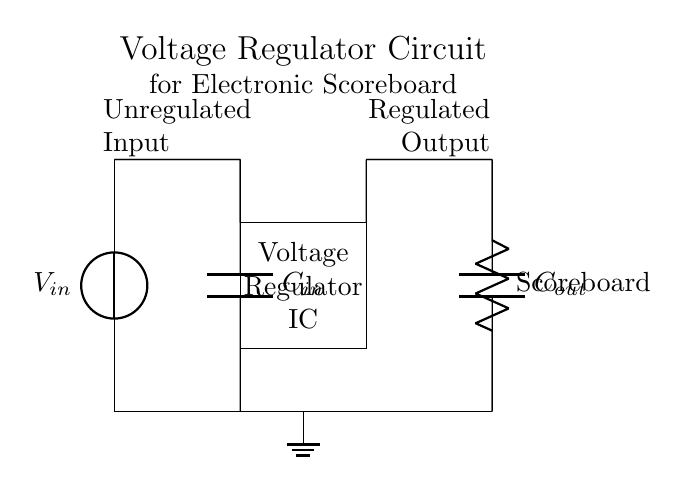What is the type of load in this circuit? The load in the circuit is an electronic scoreboard, as indicated by the label on the resistor symbol connected to the output.
Answer: Electronic Scoreboard What is the purpose of the capacitors in this circuit? The capacitors stabilize the voltage supplied to the scoreboard; the input capacitor helps filter the input voltage and the output capacitor provides stability to the output voltage.
Answer: Stabilization What component maintains the output voltage level? The voltage regulator IC is responsible for maintaining the output voltage at a specific level by regulating a varying input voltage, ensuring the load receives a steady supply.
Answer: Voltage Regulator IC What is the function of the input voltage source? The input voltage source provides the unregulated supply for the circuit, which is necessary for the operation of the voltage regulator and the load.
Answer: Supply Explain the flow of current in this circuit. Current flows from the input voltage source through the input capacitor to the voltage regulator IC, where it is regulated, and then the regulated output is supplied to the electronic scoreboard, returning to ground.
Answer: Through input to regulator to load What is the expected outcome if the output capacitor is removed? Without the output capacitor, the circuit may experience voltage fluctuations at the load due to insufficient filtering, potentially leading to erratic operation of the electronic scoreboard.
Answer: Voltage fluctuations What does the ground symbol represent? The ground symbol represents the common reference point for all voltages in the circuit, providing a return path for current flow and completing the circuit.
Answer: Common reference point 